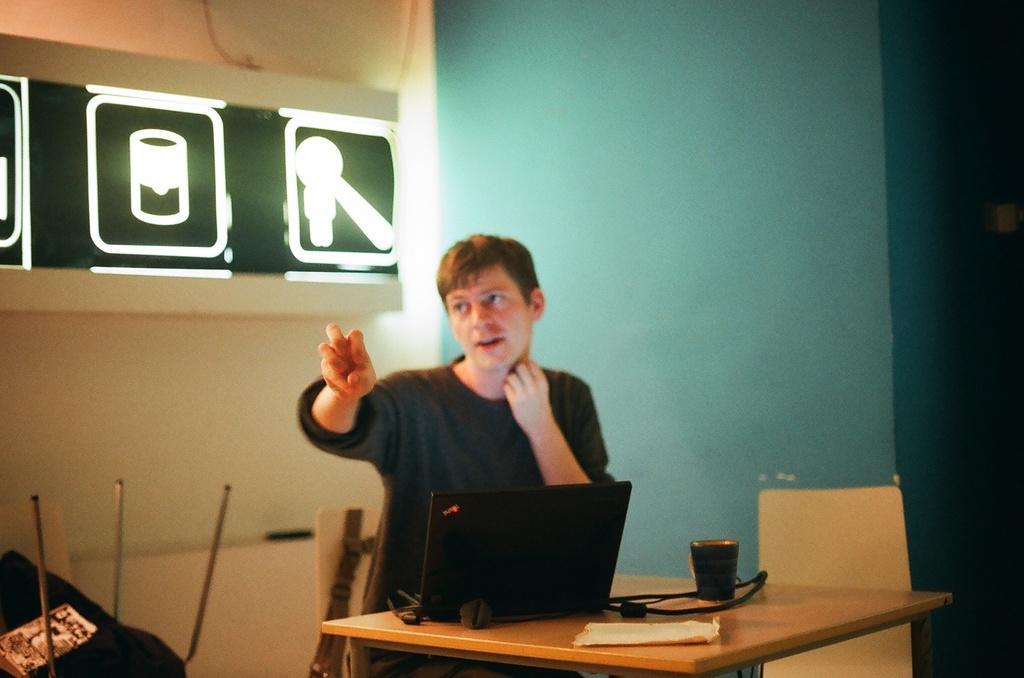How would you summarize this image in a sentence or two? This man is sitting on chair and raising his hand. In-front of this man there is a table, on a table there is a laptop, cable and cup. 